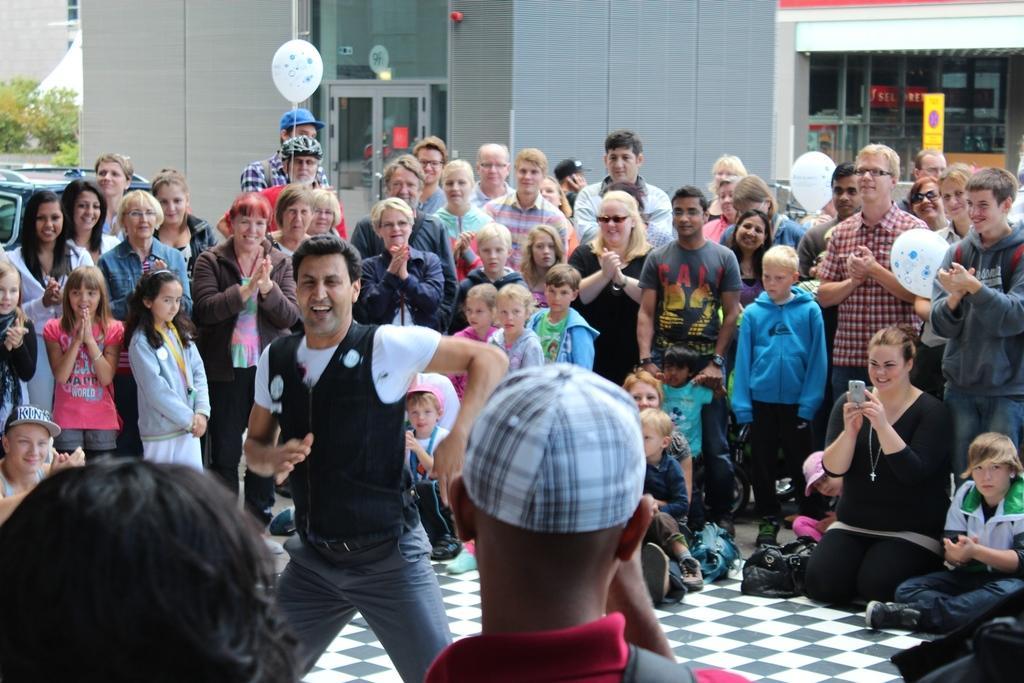How would you summarize this image in a sentence or two? In this image I can see number of persons are standing on the ground and I can see few of them are sitting. I can see a woman wearing black color dress is holding a camera in her hand. In the background I can see few buildings, few glass doors of the buildings, few trees and a yellow colored board. 